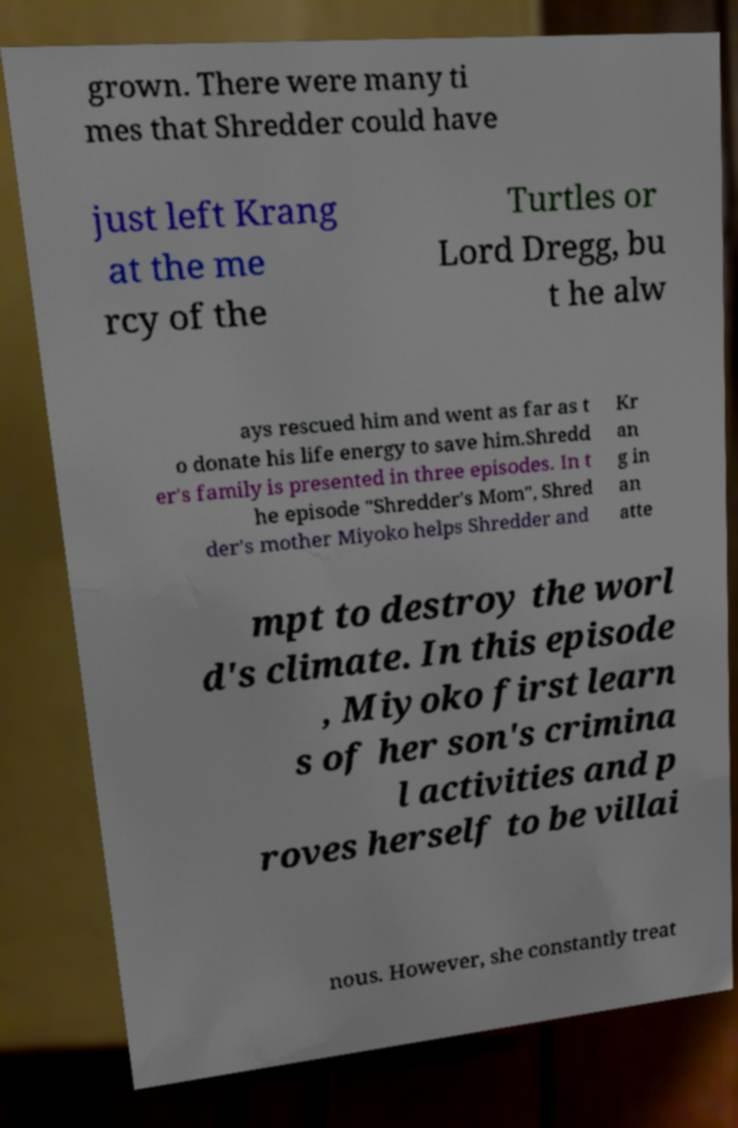There's text embedded in this image that I need extracted. Can you transcribe it verbatim? grown. There were many ti mes that Shredder could have just left Krang at the me rcy of the Turtles or Lord Dregg, bu t he alw ays rescued him and went as far as t o donate his life energy to save him.Shredd er's family is presented in three episodes. In t he episode "Shredder's Mom", Shred der's mother Miyoko helps Shredder and Kr an g in an atte mpt to destroy the worl d's climate. In this episode , Miyoko first learn s of her son's crimina l activities and p roves herself to be villai nous. However, she constantly treat 